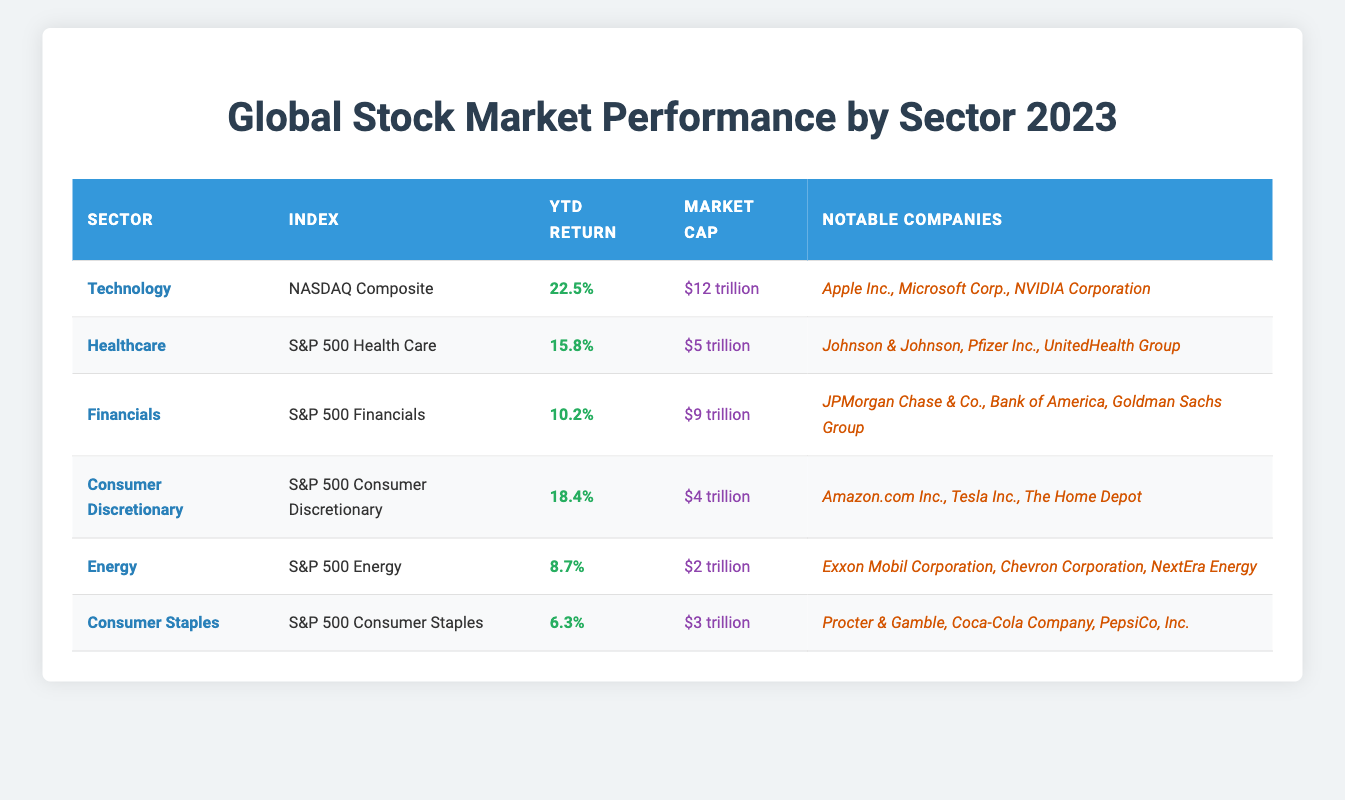What is the YTD return for the Technology sector? The YTD return for the Technology sector is listed directly in the table under the "YTD Return" column. It is shown as 22.5%.
Answer: 22.5% Which sector has the highest market cap? By examining the "Market Cap" values in the table, the highest market cap is found in the Technology sector, which is $12 trillion.
Answer: Technology How many sectors have a YTD return greater than 15%? The sectors listed with YTD returns in the table are Technology (22.5%), Healthcare (15.8%), and Consumer Discretionary (18.4%). three sectors exceed 15%.
Answer: 3 What is the average YTD return of all sectors? To find the average YTD return, sum the YTD returns of all sectors (22.5%, 15.8%, 10.2%, 18.4%, 8.7%, 6.3%). First convert percentages to decimals, then add: 0.225 + 0.158 + 0.102 + 0.184 + 0.087 + 0.063 = 0.819. Then divide by 6 (the number of sectors) to find the average: 0.819 / 6 = 0.1365, or 13.65%.
Answer: 13.65% Is it true that the Financials sector has a market cap greater than Consumer Staples? The table shows that the market cap for Financials is $9 trillion, while Consumer Staples has a market cap of $3 trillion. Since $9 trillion is greater than $3 trillion, the statement is true.
Answer: Yes Which sector had a lower YTD return: Energy or Financials? The YTD return for the Energy sector is 8.7% and for the Financials sector is 10.2%. Since 8.7% is lower than 10.2%, Energy had a lower YTD return.
Answer: Energy Which notable company belongs to the Healthcare sector? The table lists the Healthcare sector and provides notable companies including Johnson & Johnson, Pfizer Inc., and UnitedHealth Group. A notable company from the Healthcare sector is Johnson & Johnson.
Answer: Johnson & Johnson What is the total market cap of the top three sectors by market cap? The top three sectors by market cap are Technology ($12 trillion), Financials ($9 trillion), and Healthcare ($5 trillion). Add these values together: 12 + 9 + 5 = 26 trillion.
Answer: $26 trillion Which sector had a YTD return that was less than 10%? Checking the YTD returns in the table, only the Energy sector (8.7%) and Consumer Staples (6.3%) had returns less than 10%.
Answer: Energy and Consumer Staples 